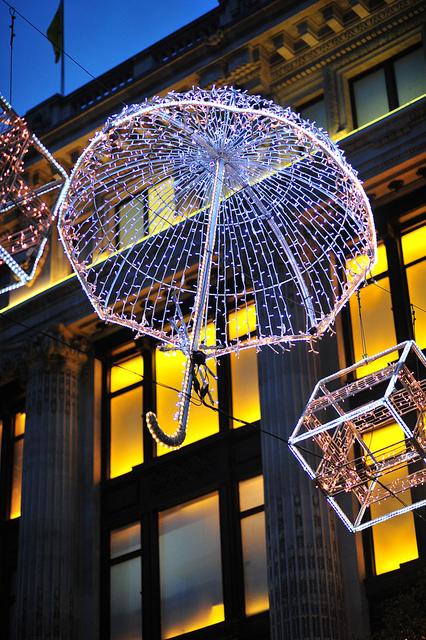What is the shape in the middle?
Give a very brief answer. Umbrella. Is dark outside?
Keep it brief. Yes. Are there lights on the objects?
Give a very brief answer. Yes. 